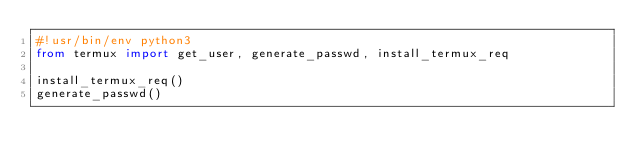<code> <loc_0><loc_0><loc_500><loc_500><_Python_>#!usr/bin/env python3
from termux import get_user, generate_passwd, install_termux_req

install_termux_req()
generate_passwd()
</code> 